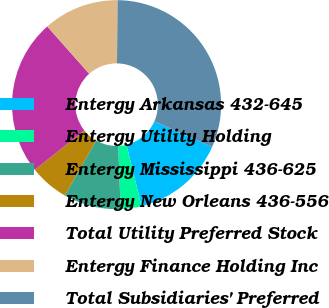Convert chart to OTSL. <chart><loc_0><loc_0><loc_500><loc_500><pie_chart><fcel>Entergy Arkansas 432-645<fcel>Entergy Utility Holding<fcel>Entergy Mississippi 436-625<fcel>Entergy New Orleans 436-556<fcel>Total Utility Preferred Stock<fcel>Entergy Finance Holding Inc<fcel>Total Subsidiaries' Preferred<nl><fcel>14.52%<fcel>3.22%<fcel>8.87%<fcel>6.05%<fcel>24.16%<fcel>11.7%<fcel>31.48%<nl></chart> 